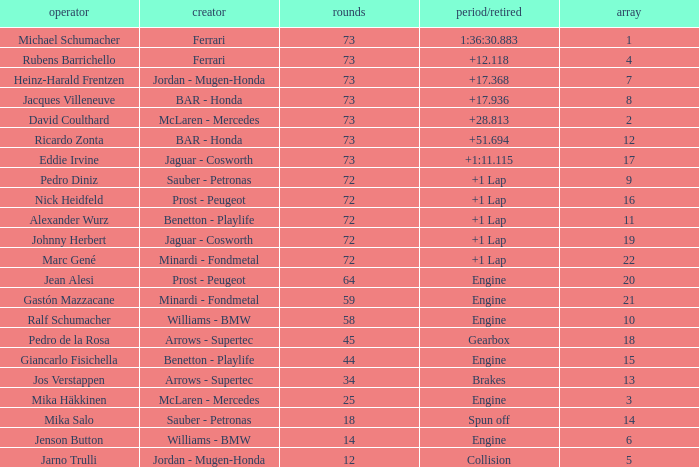How many laps did Giancarlo Fisichella do with a grid larger than 15? 0.0. 